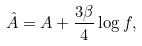<formula> <loc_0><loc_0><loc_500><loc_500>\hat { A } = A + \frac { 3 \beta } 4 \log f ,</formula> 